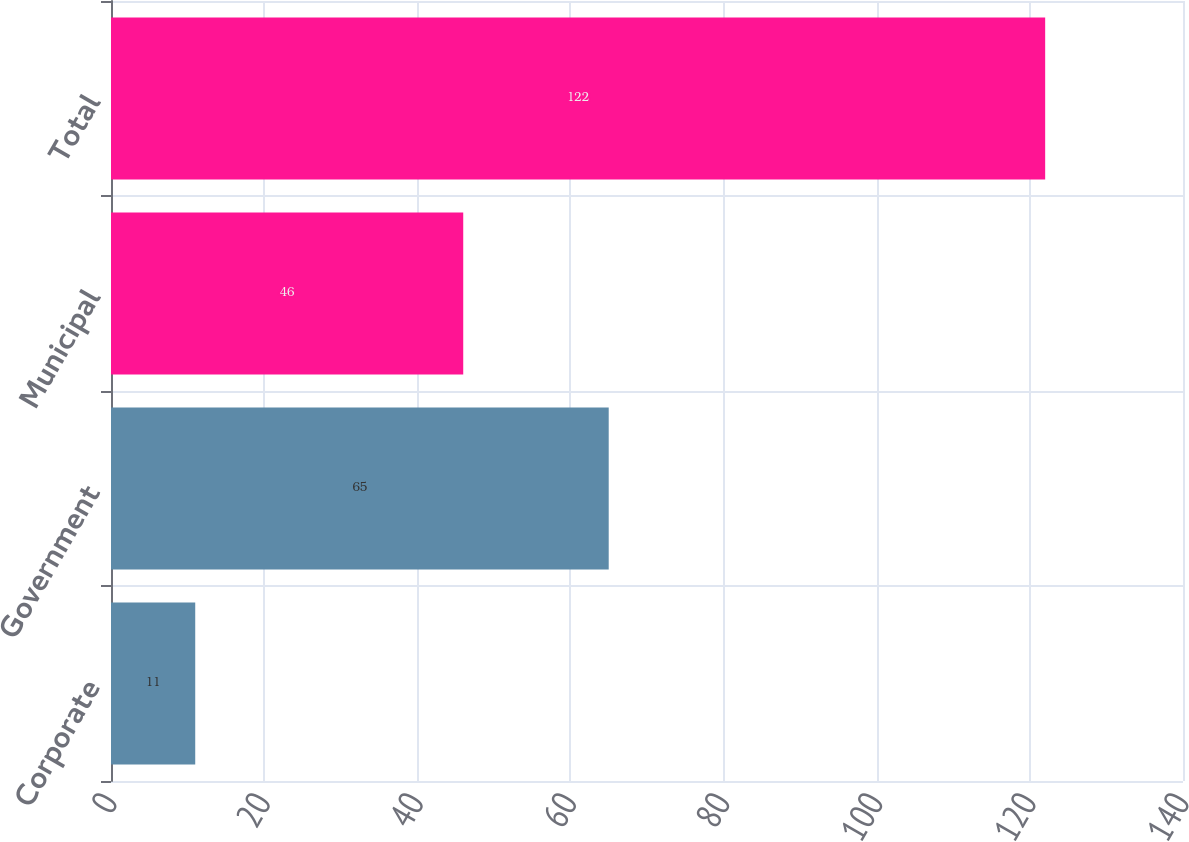Convert chart to OTSL. <chart><loc_0><loc_0><loc_500><loc_500><bar_chart><fcel>Corporate<fcel>Government<fcel>Municipal<fcel>Total<nl><fcel>11<fcel>65<fcel>46<fcel>122<nl></chart> 